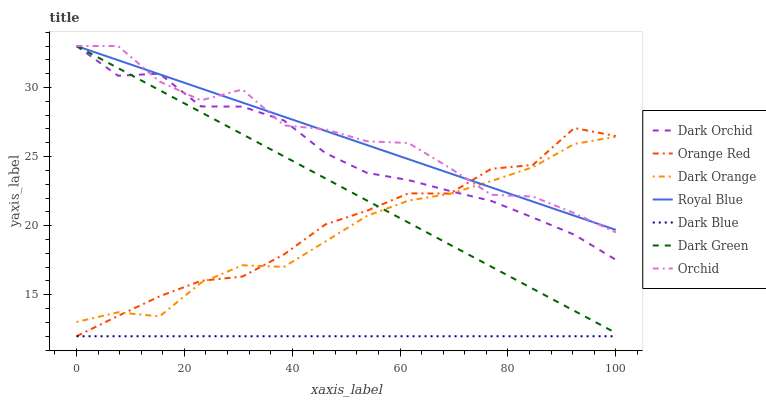Does Dark Blue have the minimum area under the curve?
Answer yes or no. Yes. Does Orchid have the maximum area under the curve?
Answer yes or no. Yes. Does Royal Blue have the minimum area under the curve?
Answer yes or no. No. Does Royal Blue have the maximum area under the curve?
Answer yes or no. No. Is Royal Blue the smoothest?
Answer yes or no. Yes. Is Orchid the roughest?
Answer yes or no. Yes. Is Dark Orchid the smoothest?
Answer yes or no. No. Is Dark Orchid the roughest?
Answer yes or no. No. Does Dark Blue have the lowest value?
Answer yes or no. Yes. Does Dark Orchid have the lowest value?
Answer yes or no. No. Does Dark Green have the highest value?
Answer yes or no. Yes. Does Dark Blue have the highest value?
Answer yes or no. No. Is Dark Blue less than Royal Blue?
Answer yes or no. Yes. Is Royal Blue greater than Dark Blue?
Answer yes or no. Yes. Does Orchid intersect Dark Green?
Answer yes or no. Yes. Is Orchid less than Dark Green?
Answer yes or no. No. Is Orchid greater than Dark Green?
Answer yes or no. No. Does Dark Blue intersect Royal Blue?
Answer yes or no. No. 